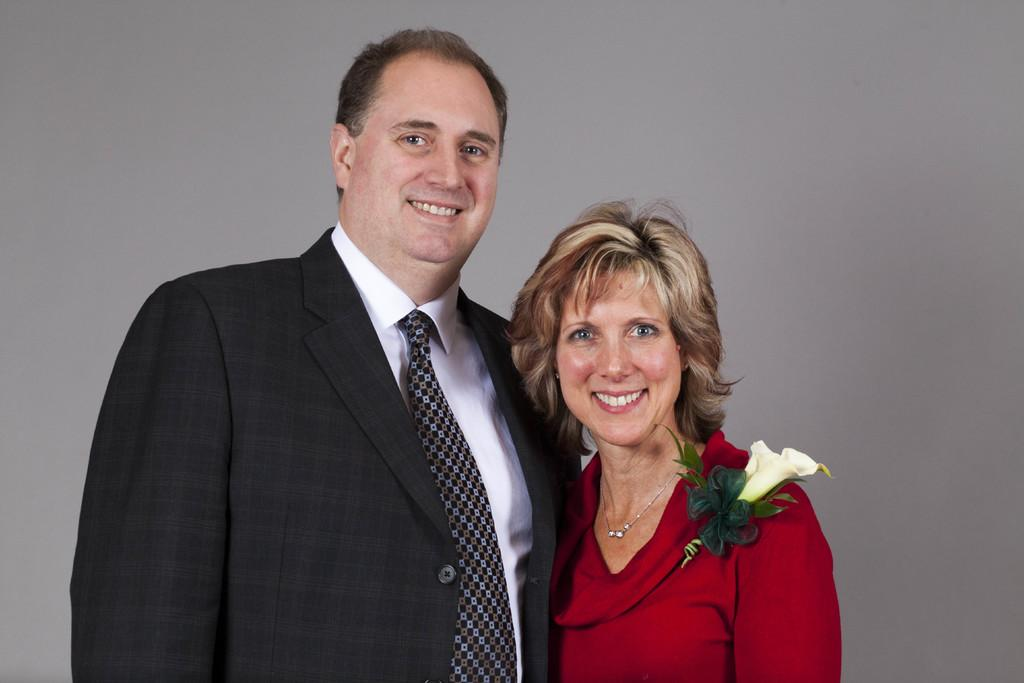Who are the people in the image? There is a man and a woman in the image. What are the man and the woman doing in the image? Both the man and the woman are standing and smiling. What can be seen in the background of the image? There is a white color wall in the background of the image. What type of discovery can be seen in the glass in the image? There is no glass or discovery present in the image. 